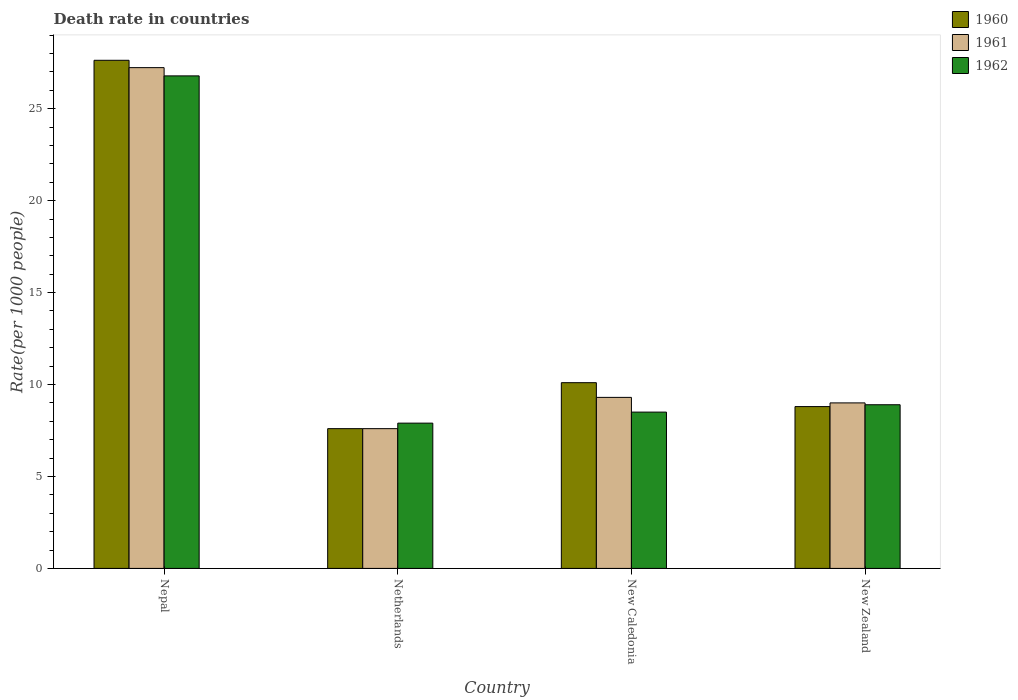How many different coloured bars are there?
Give a very brief answer. 3. Are the number of bars per tick equal to the number of legend labels?
Your answer should be very brief. Yes. Are the number of bars on each tick of the X-axis equal?
Your answer should be compact. Yes. What is the label of the 1st group of bars from the left?
Give a very brief answer. Nepal. Across all countries, what is the maximum death rate in 1960?
Your answer should be very brief. 27.63. Across all countries, what is the minimum death rate in 1960?
Provide a short and direct response. 7.6. In which country was the death rate in 1960 maximum?
Offer a very short reply. Nepal. What is the total death rate in 1960 in the graph?
Make the answer very short. 54.13. What is the difference between the death rate in 1960 in Nepal and that in New Caledonia?
Your answer should be very brief. 17.53. What is the difference between the death rate in 1961 in New Caledonia and the death rate in 1962 in New Zealand?
Offer a very short reply. 0.4. What is the average death rate in 1960 per country?
Your response must be concise. 13.53. What is the difference between the death rate of/in 1960 and death rate of/in 1961 in New Zealand?
Make the answer very short. -0.2. In how many countries, is the death rate in 1962 greater than 24?
Provide a succinct answer. 1. What is the ratio of the death rate in 1961 in Netherlands to that in New Caledonia?
Make the answer very short. 0.82. Is the difference between the death rate in 1960 in Netherlands and New Zealand greater than the difference between the death rate in 1961 in Netherlands and New Zealand?
Keep it short and to the point. Yes. What is the difference between the highest and the second highest death rate in 1961?
Your answer should be very brief. -17.93. What is the difference between the highest and the lowest death rate in 1960?
Your answer should be very brief. 20.03. In how many countries, is the death rate in 1962 greater than the average death rate in 1962 taken over all countries?
Keep it short and to the point. 1. Is the sum of the death rate in 1961 in New Caledonia and New Zealand greater than the maximum death rate in 1962 across all countries?
Your answer should be very brief. No. What does the 2nd bar from the left in New Zealand represents?
Ensure brevity in your answer.  1961. How many bars are there?
Provide a short and direct response. 12. How many countries are there in the graph?
Give a very brief answer. 4. What is the difference between two consecutive major ticks on the Y-axis?
Provide a short and direct response. 5. Are the values on the major ticks of Y-axis written in scientific E-notation?
Provide a short and direct response. No. Does the graph contain any zero values?
Keep it short and to the point. No. What is the title of the graph?
Offer a terse response. Death rate in countries. What is the label or title of the X-axis?
Provide a short and direct response. Country. What is the label or title of the Y-axis?
Your answer should be very brief. Rate(per 1000 people). What is the Rate(per 1000 people) of 1960 in Nepal?
Your answer should be very brief. 27.63. What is the Rate(per 1000 people) of 1961 in Nepal?
Provide a short and direct response. 27.23. What is the Rate(per 1000 people) in 1962 in Nepal?
Your response must be concise. 26.78. What is the Rate(per 1000 people) of 1961 in Netherlands?
Offer a terse response. 7.6. What is the Rate(per 1000 people) of 1961 in New Caledonia?
Your answer should be very brief. 9.3. What is the Rate(per 1000 people) in 1960 in New Zealand?
Ensure brevity in your answer.  8.8. What is the Rate(per 1000 people) of 1961 in New Zealand?
Your answer should be very brief. 9. Across all countries, what is the maximum Rate(per 1000 people) in 1960?
Make the answer very short. 27.63. Across all countries, what is the maximum Rate(per 1000 people) in 1961?
Provide a short and direct response. 27.23. Across all countries, what is the maximum Rate(per 1000 people) in 1962?
Make the answer very short. 26.78. Across all countries, what is the minimum Rate(per 1000 people) in 1960?
Provide a succinct answer. 7.6. Across all countries, what is the minimum Rate(per 1000 people) in 1962?
Provide a succinct answer. 7.9. What is the total Rate(per 1000 people) in 1960 in the graph?
Provide a short and direct response. 54.13. What is the total Rate(per 1000 people) in 1961 in the graph?
Provide a short and direct response. 53.13. What is the total Rate(per 1000 people) of 1962 in the graph?
Give a very brief answer. 52.08. What is the difference between the Rate(per 1000 people) in 1960 in Nepal and that in Netherlands?
Provide a succinct answer. 20.03. What is the difference between the Rate(per 1000 people) of 1961 in Nepal and that in Netherlands?
Ensure brevity in your answer.  19.63. What is the difference between the Rate(per 1000 people) of 1962 in Nepal and that in Netherlands?
Your answer should be very brief. 18.88. What is the difference between the Rate(per 1000 people) of 1960 in Nepal and that in New Caledonia?
Give a very brief answer. 17.53. What is the difference between the Rate(per 1000 people) in 1961 in Nepal and that in New Caledonia?
Make the answer very short. 17.93. What is the difference between the Rate(per 1000 people) in 1962 in Nepal and that in New Caledonia?
Give a very brief answer. 18.28. What is the difference between the Rate(per 1000 people) of 1960 in Nepal and that in New Zealand?
Provide a short and direct response. 18.83. What is the difference between the Rate(per 1000 people) of 1961 in Nepal and that in New Zealand?
Keep it short and to the point. 18.23. What is the difference between the Rate(per 1000 people) of 1962 in Nepal and that in New Zealand?
Offer a terse response. 17.88. What is the difference between the Rate(per 1000 people) of 1961 in Netherlands and that in New Caledonia?
Offer a terse response. -1.7. What is the difference between the Rate(per 1000 people) of 1962 in Netherlands and that in New Caledonia?
Provide a succinct answer. -0.6. What is the difference between the Rate(per 1000 people) in 1960 in Netherlands and that in New Zealand?
Ensure brevity in your answer.  -1.2. What is the difference between the Rate(per 1000 people) of 1962 in New Caledonia and that in New Zealand?
Your answer should be compact. -0.4. What is the difference between the Rate(per 1000 people) in 1960 in Nepal and the Rate(per 1000 people) in 1961 in Netherlands?
Your answer should be compact. 20.03. What is the difference between the Rate(per 1000 people) of 1960 in Nepal and the Rate(per 1000 people) of 1962 in Netherlands?
Make the answer very short. 19.73. What is the difference between the Rate(per 1000 people) of 1961 in Nepal and the Rate(per 1000 people) of 1962 in Netherlands?
Your answer should be very brief. 19.33. What is the difference between the Rate(per 1000 people) in 1960 in Nepal and the Rate(per 1000 people) in 1961 in New Caledonia?
Ensure brevity in your answer.  18.33. What is the difference between the Rate(per 1000 people) in 1960 in Nepal and the Rate(per 1000 people) in 1962 in New Caledonia?
Your response must be concise. 19.13. What is the difference between the Rate(per 1000 people) in 1961 in Nepal and the Rate(per 1000 people) in 1962 in New Caledonia?
Your response must be concise. 18.73. What is the difference between the Rate(per 1000 people) of 1960 in Nepal and the Rate(per 1000 people) of 1961 in New Zealand?
Your response must be concise. 18.63. What is the difference between the Rate(per 1000 people) in 1960 in Nepal and the Rate(per 1000 people) in 1962 in New Zealand?
Provide a short and direct response. 18.73. What is the difference between the Rate(per 1000 people) in 1961 in Nepal and the Rate(per 1000 people) in 1962 in New Zealand?
Offer a terse response. 18.33. What is the difference between the Rate(per 1000 people) in 1960 in Netherlands and the Rate(per 1000 people) in 1961 in New Caledonia?
Ensure brevity in your answer.  -1.7. What is the difference between the Rate(per 1000 people) in 1960 in Netherlands and the Rate(per 1000 people) in 1962 in New Caledonia?
Make the answer very short. -0.9. What is the difference between the Rate(per 1000 people) of 1961 in Netherlands and the Rate(per 1000 people) of 1962 in New Zealand?
Provide a succinct answer. -1.3. What is the difference between the Rate(per 1000 people) in 1960 in New Caledonia and the Rate(per 1000 people) in 1961 in New Zealand?
Offer a very short reply. 1.1. What is the difference between the Rate(per 1000 people) of 1961 in New Caledonia and the Rate(per 1000 people) of 1962 in New Zealand?
Provide a short and direct response. 0.4. What is the average Rate(per 1000 people) in 1960 per country?
Your answer should be very brief. 13.53. What is the average Rate(per 1000 people) of 1961 per country?
Offer a very short reply. 13.28. What is the average Rate(per 1000 people) of 1962 per country?
Provide a short and direct response. 13.02. What is the difference between the Rate(per 1000 people) of 1960 and Rate(per 1000 people) of 1961 in Nepal?
Keep it short and to the point. 0.4. What is the difference between the Rate(per 1000 people) of 1960 and Rate(per 1000 people) of 1962 in Nepal?
Your answer should be very brief. 0.85. What is the difference between the Rate(per 1000 people) in 1961 and Rate(per 1000 people) in 1962 in Nepal?
Offer a very short reply. 0.45. What is the difference between the Rate(per 1000 people) of 1960 and Rate(per 1000 people) of 1961 in Netherlands?
Offer a very short reply. 0. What is the difference between the Rate(per 1000 people) in 1961 and Rate(per 1000 people) in 1962 in Netherlands?
Your answer should be very brief. -0.3. What is the difference between the Rate(per 1000 people) of 1960 and Rate(per 1000 people) of 1962 in New Caledonia?
Your answer should be compact. 1.6. What is the difference between the Rate(per 1000 people) of 1960 and Rate(per 1000 people) of 1962 in New Zealand?
Provide a succinct answer. -0.1. What is the difference between the Rate(per 1000 people) of 1961 and Rate(per 1000 people) of 1962 in New Zealand?
Offer a terse response. 0.1. What is the ratio of the Rate(per 1000 people) in 1960 in Nepal to that in Netherlands?
Keep it short and to the point. 3.64. What is the ratio of the Rate(per 1000 people) in 1961 in Nepal to that in Netherlands?
Offer a terse response. 3.58. What is the ratio of the Rate(per 1000 people) of 1962 in Nepal to that in Netherlands?
Your answer should be compact. 3.39. What is the ratio of the Rate(per 1000 people) in 1960 in Nepal to that in New Caledonia?
Offer a very short reply. 2.74. What is the ratio of the Rate(per 1000 people) in 1961 in Nepal to that in New Caledonia?
Your answer should be very brief. 2.93. What is the ratio of the Rate(per 1000 people) in 1962 in Nepal to that in New Caledonia?
Provide a succinct answer. 3.15. What is the ratio of the Rate(per 1000 people) of 1960 in Nepal to that in New Zealand?
Your answer should be compact. 3.14. What is the ratio of the Rate(per 1000 people) of 1961 in Nepal to that in New Zealand?
Your answer should be very brief. 3.03. What is the ratio of the Rate(per 1000 people) of 1962 in Nepal to that in New Zealand?
Offer a terse response. 3.01. What is the ratio of the Rate(per 1000 people) of 1960 in Netherlands to that in New Caledonia?
Provide a short and direct response. 0.75. What is the ratio of the Rate(per 1000 people) in 1961 in Netherlands to that in New Caledonia?
Your answer should be very brief. 0.82. What is the ratio of the Rate(per 1000 people) in 1962 in Netherlands to that in New Caledonia?
Ensure brevity in your answer.  0.93. What is the ratio of the Rate(per 1000 people) in 1960 in Netherlands to that in New Zealand?
Provide a short and direct response. 0.86. What is the ratio of the Rate(per 1000 people) of 1961 in Netherlands to that in New Zealand?
Offer a terse response. 0.84. What is the ratio of the Rate(per 1000 people) of 1962 in Netherlands to that in New Zealand?
Offer a terse response. 0.89. What is the ratio of the Rate(per 1000 people) of 1960 in New Caledonia to that in New Zealand?
Your response must be concise. 1.15. What is the ratio of the Rate(per 1000 people) in 1961 in New Caledonia to that in New Zealand?
Your answer should be very brief. 1.03. What is the ratio of the Rate(per 1000 people) of 1962 in New Caledonia to that in New Zealand?
Your answer should be compact. 0.96. What is the difference between the highest and the second highest Rate(per 1000 people) of 1960?
Offer a terse response. 17.53. What is the difference between the highest and the second highest Rate(per 1000 people) of 1961?
Offer a very short reply. 17.93. What is the difference between the highest and the second highest Rate(per 1000 people) in 1962?
Your response must be concise. 17.88. What is the difference between the highest and the lowest Rate(per 1000 people) of 1960?
Make the answer very short. 20.03. What is the difference between the highest and the lowest Rate(per 1000 people) in 1961?
Your answer should be compact. 19.63. What is the difference between the highest and the lowest Rate(per 1000 people) in 1962?
Make the answer very short. 18.88. 